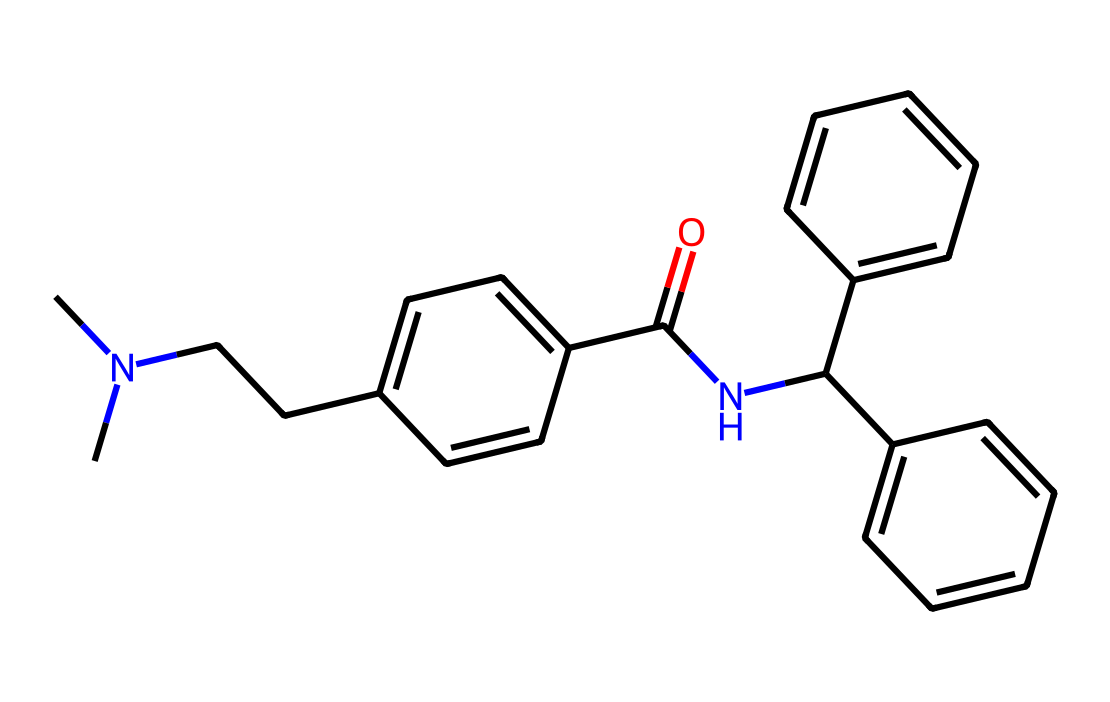How many nitrogen atoms are present in this chemical? By analyzing the chemical structure, one can identify that there are two nitrogen atoms (N) in the molecule, indicated by the presence of two "N" symbols in the SMILES representation.
Answer: two What is the primary functional group present in this chemical? The structure contains an amide group, which can be identified by the carbon connected to a nitrogen and is part of a carbonyl function (C=O). This is indicated by the presence of "C(=O)N" in the SMILES notation.
Answer: amide Which part of the molecule is likely responsible for opioid-like effects? The presence of specific benzene rings and nitrogen atoms (indicative of basic amine groups) suggests that the molecule might interact with opioid receptors, characteristic of many opioid analogs.
Answer: benzene rings and nitrogen What is the total number of carbon atoms in the molecule? By counting the number of "C" symbols in the SMILES representation, there are 22 carbon atoms in total within this chemical structure.
Answer: twenty-two What type of reaction might this drug undergo in the body? Given the presence of the amide and aromatic rings in the structure, this drug might undergo hydrolysis or metabolic transformations involving cytochrome P450 enzymes, common for drugs in the body.
Answer: hydrolysis How does the presence of multiple rings affect the pharmacokinetics of this drug? The presence of multiple aromatic rings can increase lipophilicity, which typically enhances absorption and distribution in the body, influencing overall pharmacokinetics.
Answer: increased lipophilicity What implications does this drug have legally given its similarity to fentanyl? Its similarity to fentanyl may classify it under controlled substances due to potential for abuse and serious health risks associated with opioid compounds, drawing legal attention and implications.
Answer: controlled substance classification 